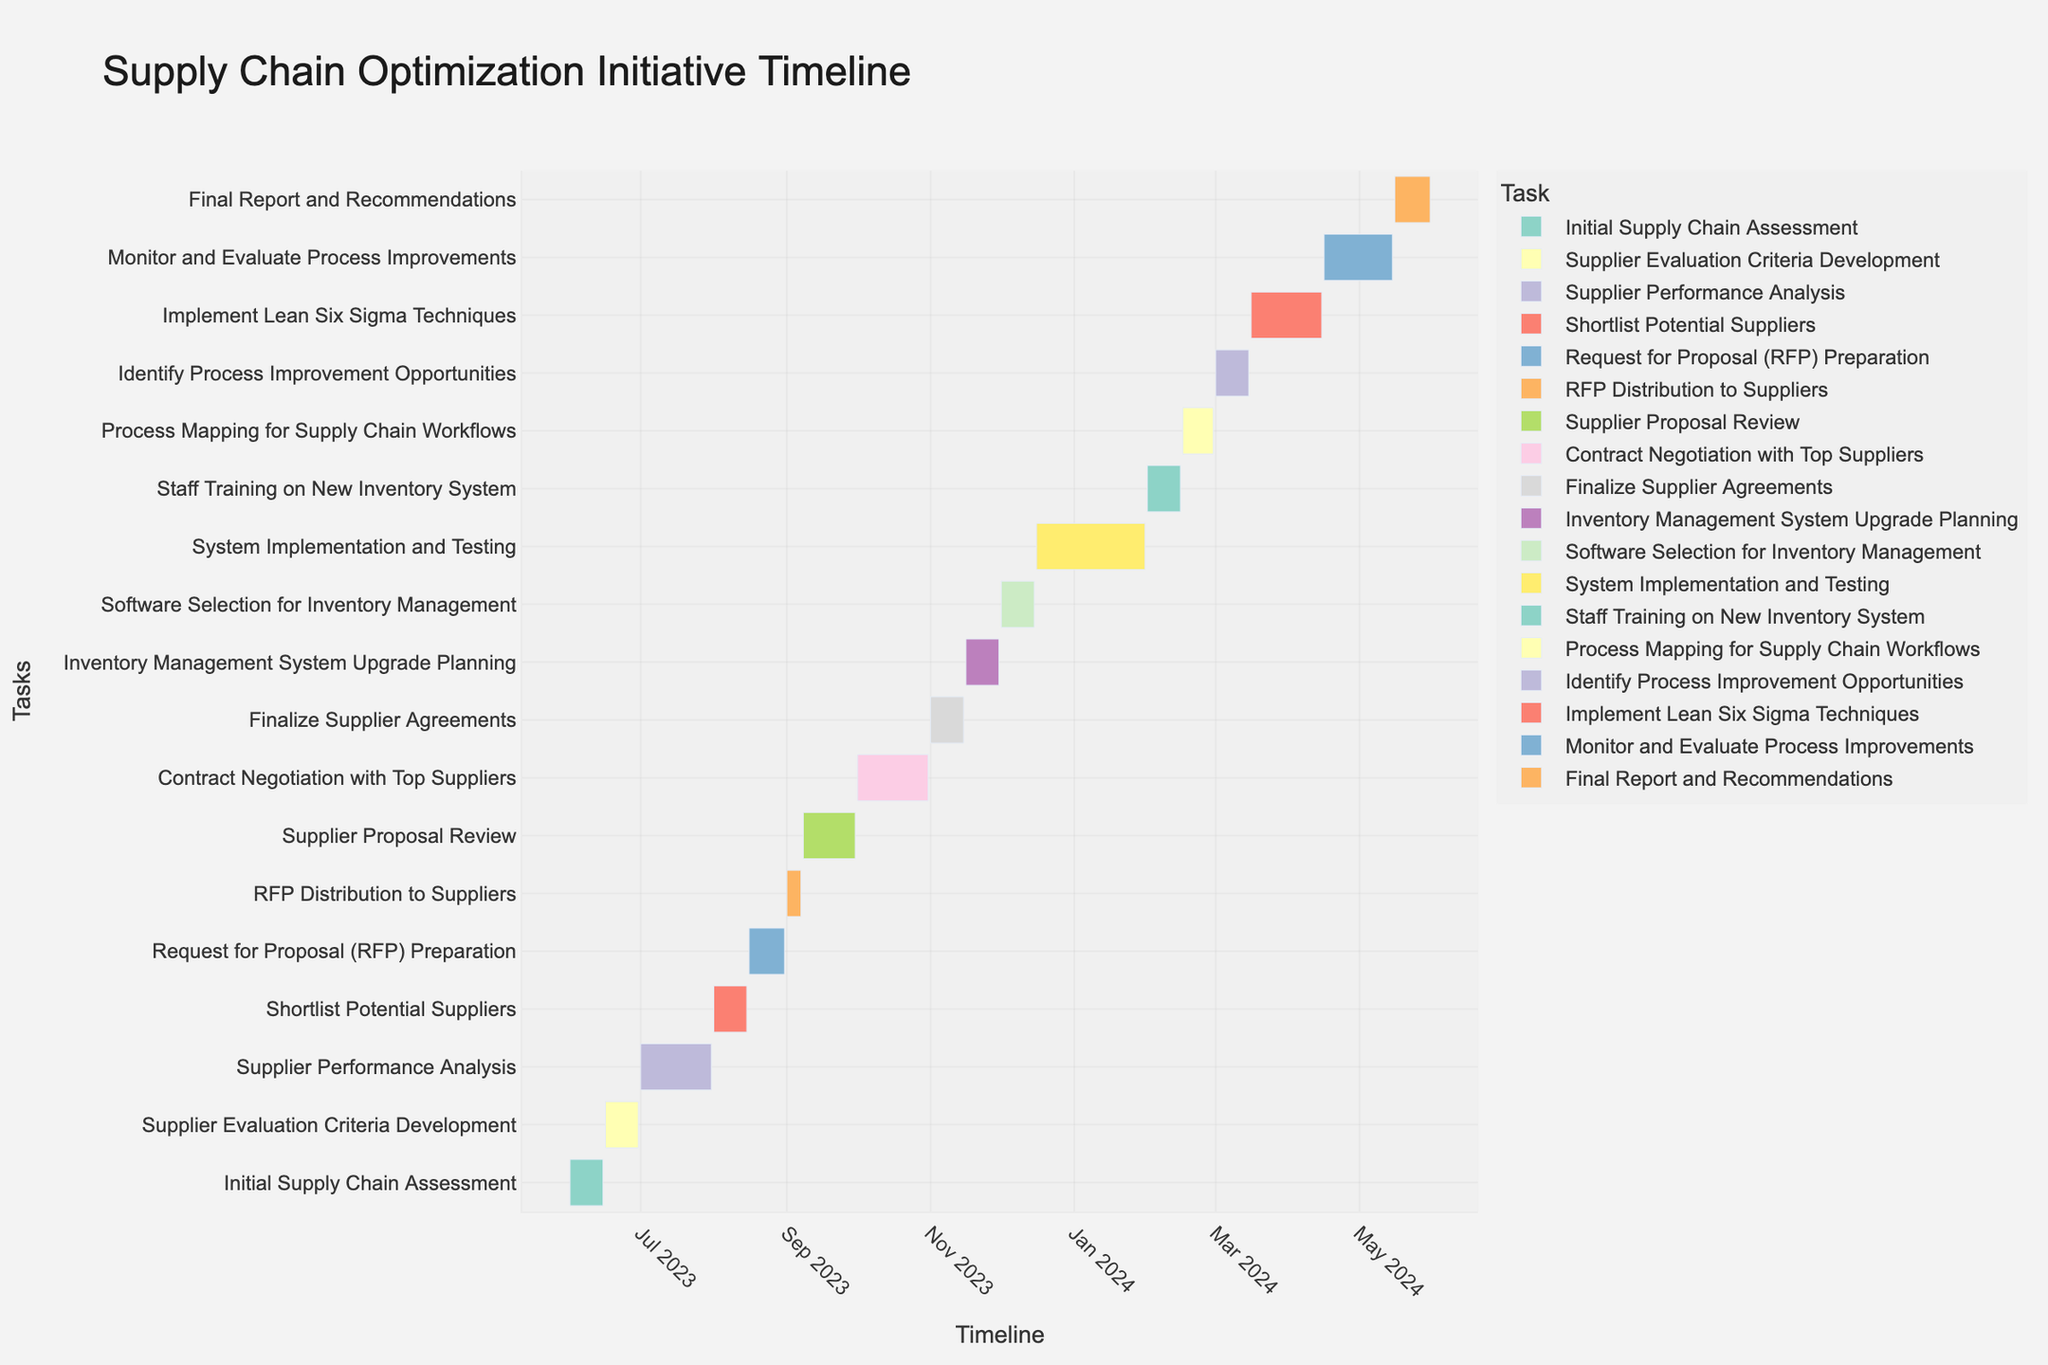What is the overall title of the chart? The overall title is located at the top of the chart and provides a summary of the visualized data. By looking at the top of the figure, we can identify that the title is "Supply Chain Optimization Initiative Timeline".
Answer: Supply Chain Optimization Initiative Timeline How long is the 'Supplier Performance Analysis' stage? To calculate the duration of the 'Supplier Performance Analysis' stage, we need to find the difference between the start and end dates. The start date is July 1, 2023, and the end date is July 31, 2023. The duration is from July 1 to July 31.
Answer: 31 days Which tasks are scheduled to end in November 2023? By visually inspecting the figure, we can identify which tasks end within the time range covered by November 2023. The 'Finalize Supplier Agreements' ends on November 15, 2023, and the 'Inventory Management System Upgrade Planning' ends on November 30, 2023.
Answer: Finalize Supplier Agreements, Inventory Management System Upgrade Planning Which task takes place immediately after 'Contract Negotiation with Top Suppliers'? By looking at the placement and sequence of tasks on the chart, we see that 'Contract Negotiation with Top Suppliers' ends on October 31, 2023. The task immediately following this is 'Finalize Supplier Agreements' which starts on November 1, 2023.
Answer: Finalize Supplier Agreements What is the duration of the 'System Implementation and Testing' stage in weeks? To determine the duration in weeks, we need to calculate the number of days from the start date to the end date and then convert this into weeks. 'System Implementation and Testing' starts on December 16, 2023, and ends on January 31, 2024. The total duration is 47 days, which converts to approximately 6.7 weeks.
Answer: ~6.7 weeks How does the duration of 'Request for Proposal (RFP) Preparation' compare to that of 'RFP Distribution to Suppliers'? To compare the durations: 'Request for Proposal (RFP) Preparation' runs from August 16 to August 31, 2023 (15 days), and 'RFP Distribution to Suppliers' runs from September 1 to September 7, 2023 (7 days). 'Request for Proposal (RFP) Preparation' is longer.
Answer: RFP Preparation is 8 days longer Which two stages have the exact same duration? By comparing the durations of each task, we find that 'Shortlist Potential Suppliers' (August 1 to August 15, 2023) and 'Supplier Evaluation Criteria Development' (June 16 to June 30, 2023) both last 15 days.
Answer: Shortlist Potential Suppliers, Supplier Evaluation Criteria Development When does the 'Staff Training on New Inventory System' start and end? By identifying the specific task in the chart, 'Staff Training on New Inventory System' starts on February 1, 2024, and ends on February 15, 2024.
Answer: February 1, 2024 - February 15, 2024 Is the duration of 'Monitor and Evaluate Process Improvements' shorter than that of 'Implement Lean Six Sigma Techniques'? 'Monitor and Evaluate Process Improvements' runs from April 16 to May 15, 2024 (30 days), and 'Implement Lean Six Sigma Techniques' spans from March 16 to April 15, 2024 (31 days). Thus, 'Monitor and Evaluate Process Improvements' is indeed shorter.
Answer: Yes What is the final task in the timeline? By looking at the sequence of tasks and their endpoints, the last task in the timeline is 'Final Report and Recommendations', which ends on May 31, 2024.
Answer: Final Report and Recommendations 